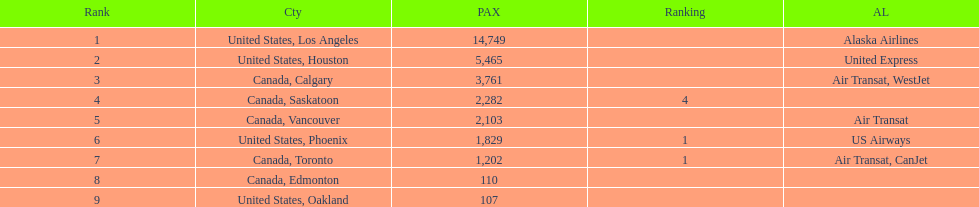How many cities from canada are on this list? 5. 